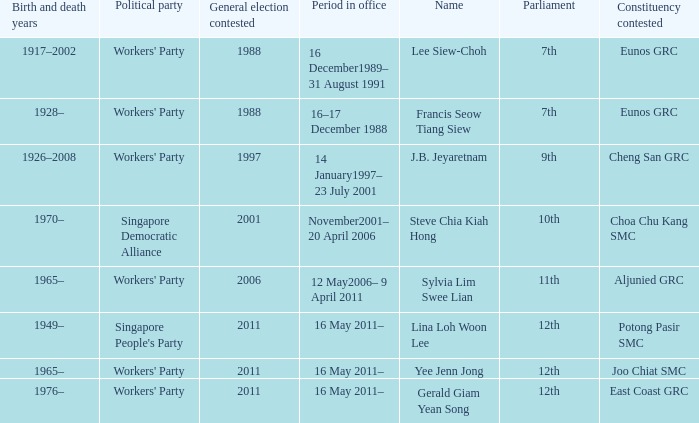During what period were parliament 11th? 12 May2006– 9 April 2011. 